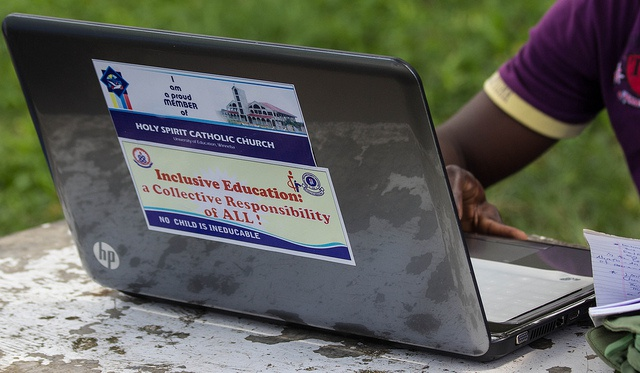Describe the objects in this image and their specific colors. I can see laptop in green, gray, black, darkgray, and navy tones and people in green, black, gray, maroon, and purple tones in this image. 